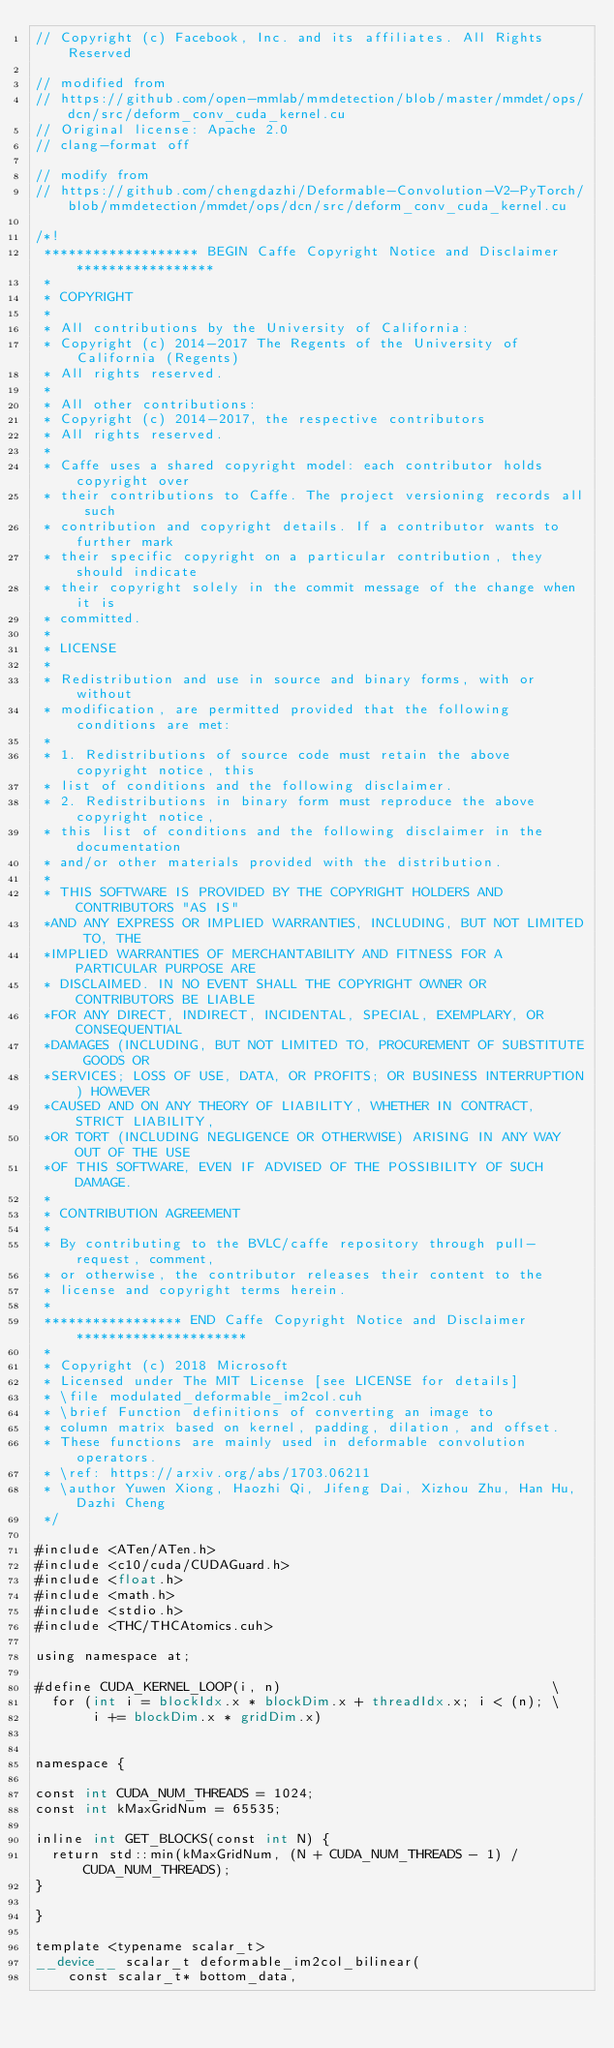<code> <loc_0><loc_0><loc_500><loc_500><_Cuda_>// Copyright (c) Facebook, Inc. and its affiliates. All Rights Reserved

// modified from
// https://github.com/open-mmlab/mmdetection/blob/master/mmdet/ops/dcn/src/deform_conv_cuda_kernel.cu
// Original license: Apache 2.0
// clang-format off

// modify from
// https://github.com/chengdazhi/Deformable-Convolution-V2-PyTorch/blob/mmdetection/mmdet/ops/dcn/src/deform_conv_cuda_kernel.cu

/*!
 ******************* BEGIN Caffe Copyright Notice and Disclaimer *****************
 *
 * COPYRIGHT
 *
 * All contributions by the University of California:
 * Copyright (c) 2014-2017 The Regents of the University of California (Regents)
 * All rights reserved.
 *
 * All other contributions:
 * Copyright (c) 2014-2017, the respective contributors
 * All rights reserved.
 *
 * Caffe uses a shared copyright model: each contributor holds copyright over
 * their contributions to Caffe. The project versioning records all such
 * contribution and copyright details. If a contributor wants to further mark
 * their specific copyright on a particular contribution, they should indicate
 * their copyright solely in the commit message of the change when it is
 * committed.
 *
 * LICENSE
 *
 * Redistribution and use in source and binary forms, with or without
 * modification, are permitted provided that the following conditions are met:
 *
 * 1. Redistributions of source code must retain the above copyright notice, this
 * list of conditions and the following disclaimer.
 * 2. Redistributions in binary form must reproduce the above copyright notice,
 * this list of conditions and the following disclaimer in the documentation
 * and/or other materials provided with the distribution.
 *
 * THIS SOFTWARE IS PROVIDED BY THE COPYRIGHT HOLDERS AND CONTRIBUTORS "AS IS"
 *AND ANY EXPRESS OR IMPLIED WARRANTIES, INCLUDING, BUT NOT LIMITED TO, THE
 *IMPLIED WARRANTIES OF MERCHANTABILITY AND FITNESS FOR A PARTICULAR PURPOSE ARE
 * DISCLAIMED. IN NO EVENT SHALL THE COPYRIGHT OWNER OR CONTRIBUTORS BE LIABLE
 *FOR ANY DIRECT, INDIRECT, INCIDENTAL, SPECIAL, EXEMPLARY, OR CONSEQUENTIAL
 *DAMAGES (INCLUDING, BUT NOT LIMITED TO, PROCUREMENT OF SUBSTITUTE GOODS OR
 *SERVICES; LOSS OF USE, DATA, OR PROFITS; OR BUSINESS INTERRUPTION) HOWEVER
 *CAUSED AND ON ANY THEORY OF LIABILITY, WHETHER IN CONTRACT, STRICT LIABILITY,
 *OR TORT (INCLUDING NEGLIGENCE OR OTHERWISE) ARISING IN ANY WAY OUT OF THE USE
 *OF THIS SOFTWARE, EVEN IF ADVISED OF THE POSSIBILITY OF SUCH DAMAGE.
 *
 * CONTRIBUTION AGREEMENT
 *
 * By contributing to the BVLC/caffe repository through pull-request, comment,
 * or otherwise, the contributor releases their content to the
 * license and copyright terms herein.
 *
 ***************** END Caffe Copyright Notice and Disclaimer *********************
 *
 * Copyright (c) 2018 Microsoft
 * Licensed under The MIT License [see LICENSE for details]
 * \file modulated_deformable_im2col.cuh
 * \brief Function definitions of converting an image to
 * column matrix based on kernel, padding, dilation, and offset.
 * These functions are mainly used in deformable convolution operators.
 * \ref: https://arxiv.org/abs/1703.06211
 * \author Yuwen Xiong, Haozhi Qi, Jifeng Dai, Xizhou Zhu, Han Hu, Dazhi Cheng
 */

#include <ATen/ATen.h>
#include <c10/cuda/CUDAGuard.h>
#include <float.h>
#include <math.h>
#include <stdio.h>
#include <THC/THCAtomics.cuh>

using namespace at;

#define CUDA_KERNEL_LOOP(i, n)                                 \
  for (int i = blockIdx.x * blockDim.x + threadIdx.x; i < (n); \
       i += blockDim.x * gridDim.x)


namespace {

const int CUDA_NUM_THREADS = 1024;
const int kMaxGridNum = 65535;

inline int GET_BLOCKS(const int N) {
  return std::min(kMaxGridNum, (N + CUDA_NUM_THREADS - 1) / CUDA_NUM_THREADS);
}

}

template <typename scalar_t>
__device__ scalar_t deformable_im2col_bilinear(
    const scalar_t* bottom_data,</code> 